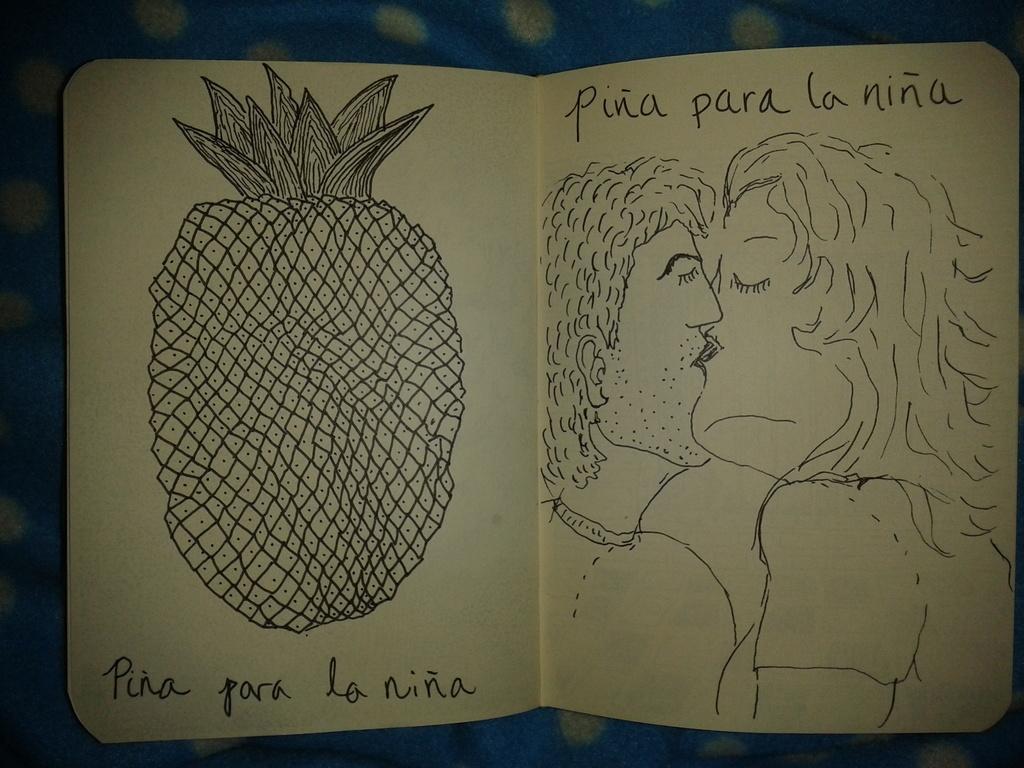How would you summarize this image in a sentence or two? In this image I can see drawings are on the papers. Something is written on the papers. In the background of the image there is a cloth.   